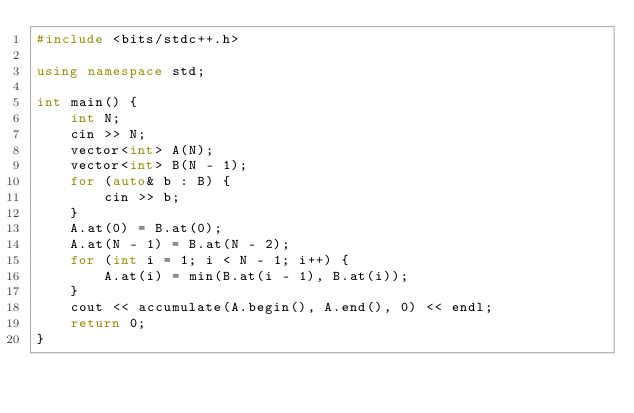<code> <loc_0><loc_0><loc_500><loc_500><_C++_>#include <bits/stdc++.h>

using namespace std;

int main() {
    int N;
    cin >> N;
    vector<int> A(N);
    vector<int> B(N - 1);
    for (auto& b : B) {
        cin >> b;
    }
    A.at(0) = B.at(0);
    A.at(N - 1) = B.at(N - 2);
    for (int i = 1; i < N - 1; i++) {
        A.at(i) = min(B.at(i - 1), B.at(i));
    }
    cout << accumulate(A.begin(), A.end(), 0) << endl;
    return 0;
}
</code> 